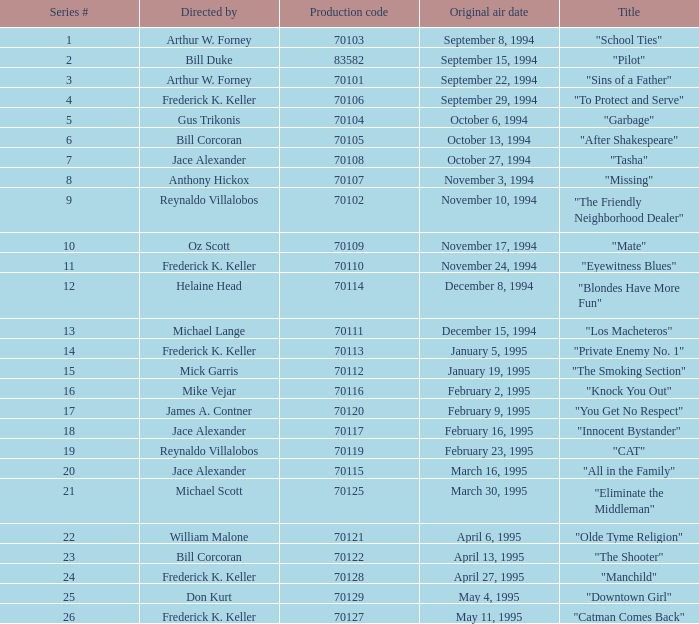For the "Downtown Girl" episode, what was the original air date? May 4, 1995. 